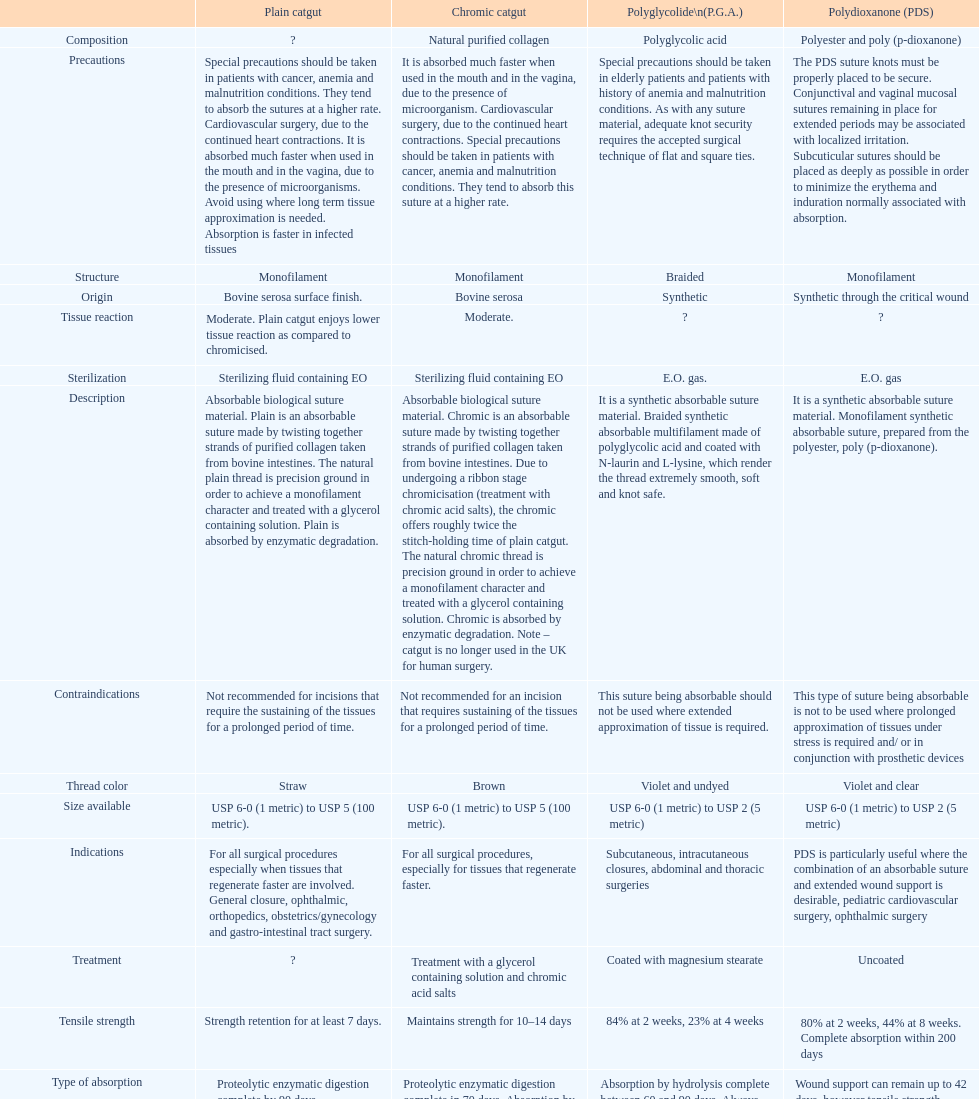What is the structure other than monofilament Braided. 